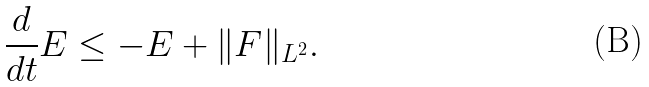Convert formula to latex. <formula><loc_0><loc_0><loc_500><loc_500>\frac { d } { d t } E \leq - E + \| F \| _ { L ^ { 2 } } .</formula> 